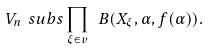<formula> <loc_0><loc_0><loc_500><loc_500>V _ { n } \ s u b s \prod _ { \xi \in v } \ B ( X _ { \xi } , \alpha , f ( \alpha ) ) .</formula> 